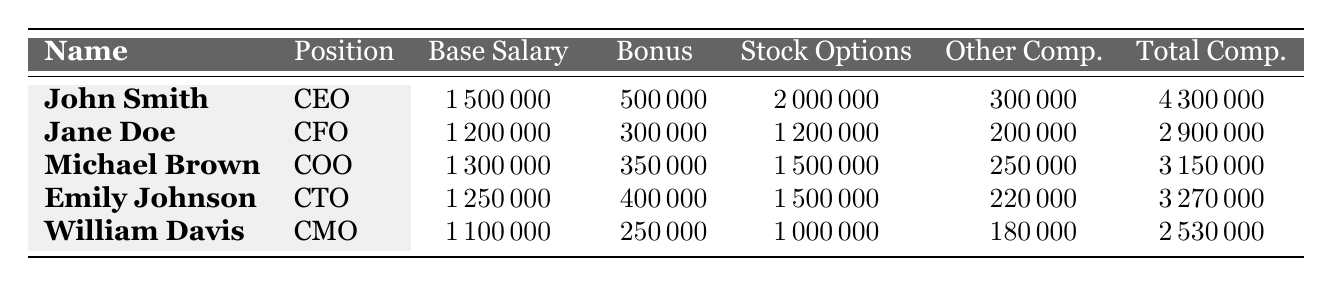What is the total compensation for the CEO? The CEO's row in the table shows the total compensation of John Smith, which is listed as 4,300,000.
Answer: 4,300,000 What is the base salary of the CFO? The CFO's row indicates that Jane Doe has a base salary of 1,200,000.
Answer: 1,200,000 Which executive received the highest stock options? By comparing the Stock Options column, John Smith has stock options listed at 2,000,000, which is the highest among all executives.
Answer: John Smith What is the total compensation for all executives combined? To find the total, sum the Total Compensation values: 4,300,000 + 2,900,000 + 3,150,000 + 3,270,000 + 2,530,000 = 16,150,000.
Answer: 16,150,000 Is Emily Johnson's total compensation greater than that of William Davis? Comparing the total compensations, Emily Johnson has 3,270,000, and William Davis has 2,530,000. Since 3,270,000 > 2,530,000, the statement is true.
Answer: Yes What is the average base salary of the executives listed? The average base salary is calculated as (1,500,000 + 1,200,000 + 1,300,000 + 1,250,000 + 1,100,000)/5 = 1,270,000.
Answer: 1,270,000 Who has the second highest total compensation? The total compensations in descending order are John Smith, Emily Johnson, Michael Brown, Jane Doe, and William Davis. Therefore, the second highest is Emily Johnson.
Answer: Emily Johnson What is the difference between the total compensation of the CEO and the CMO? The difference is calculated by subtracting the CMO's total compensation (2,530,000) from the CEO's total compensation (4,300,000): 4,300,000 - 2,530,000 = 1,770,000.
Answer: 1,770,000 Which position has the lowest base salary? By examining the Base Salary column, the lowest figure is 1,100,000 associated with the CMO, William Davis.
Answer: CMO Are bonuses generally higher for CTOs than for CFOs? The CFO, Jane Doe, has a bonus of 300,000 while the CTO, Emily Johnson, has a bonus of 400,000. Since 400,000 > 300,000, the statement is true.
Answer: Yes What is the total value of "Other Compensation" for all executives? Summing the Other Compensation values: 300,000 + 200,000 + 250,000 + 220,000 + 180,000 = 1,150,000 gives the total.
Answer: 1,150,000 